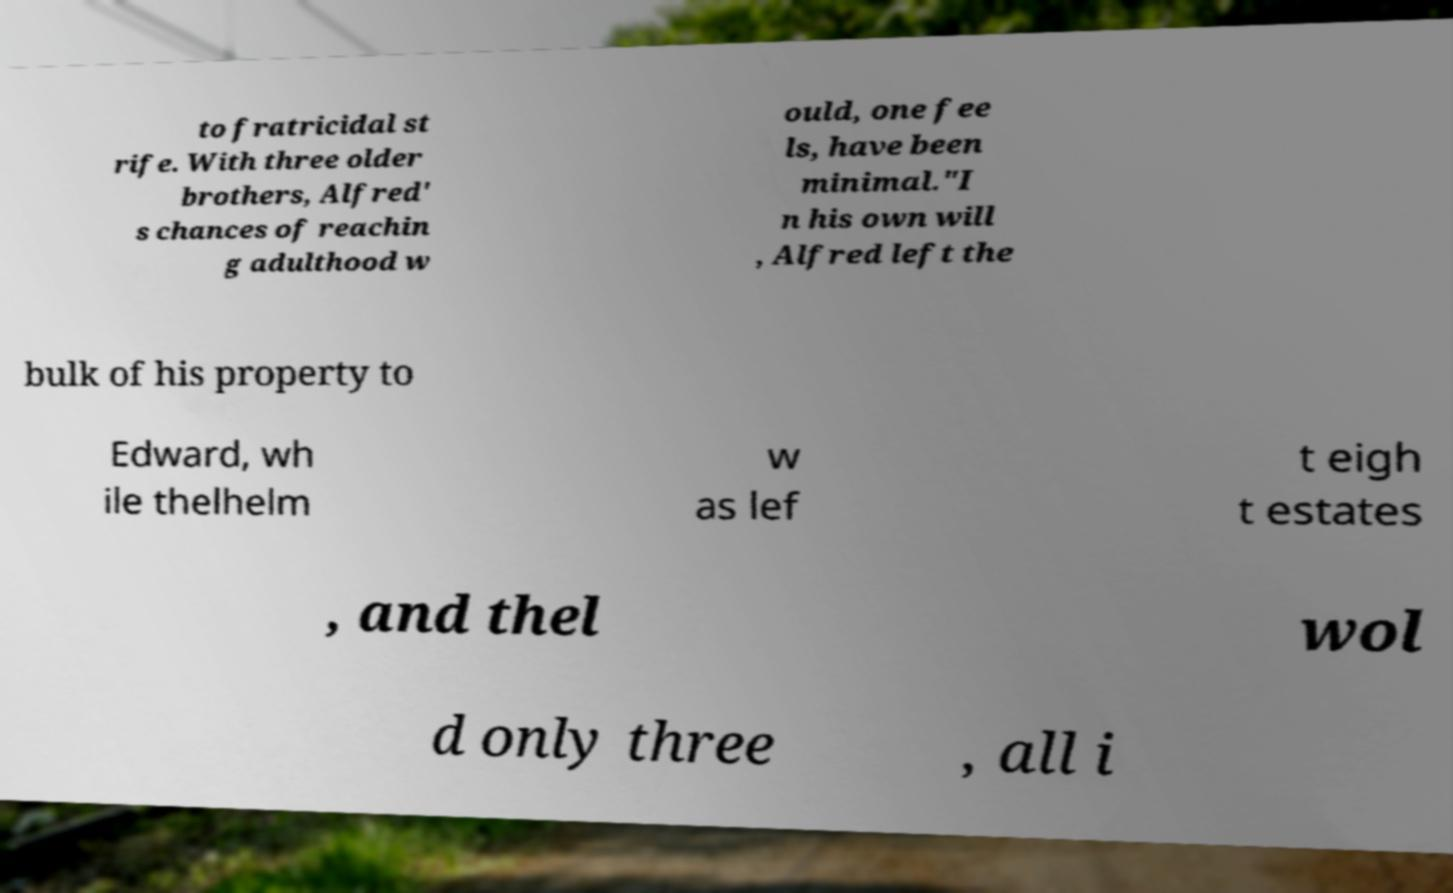I need the written content from this picture converted into text. Can you do that? to fratricidal st rife. With three older brothers, Alfred' s chances of reachin g adulthood w ould, one fee ls, have been minimal."I n his own will , Alfred left the bulk of his property to Edward, wh ile thelhelm w as lef t eigh t estates , and thel wol d only three , all i 